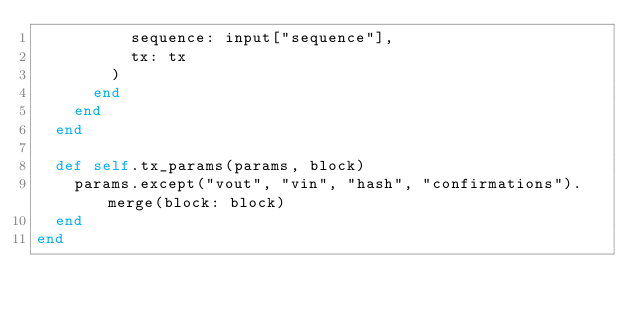<code> <loc_0><loc_0><loc_500><loc_500><_Ruby_>          sequence: input["sequence"],
          tx: tx
        )
      end
    end
  end

  def self.tx_params(params, block)
    params.except("vout", "vin", "hash", "confirmations").merge(block: block)
  end
end
</code> 